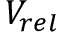<formula> <loc_0><loc_0><loc_500><loc_500>V _ { r e l }</formula> 